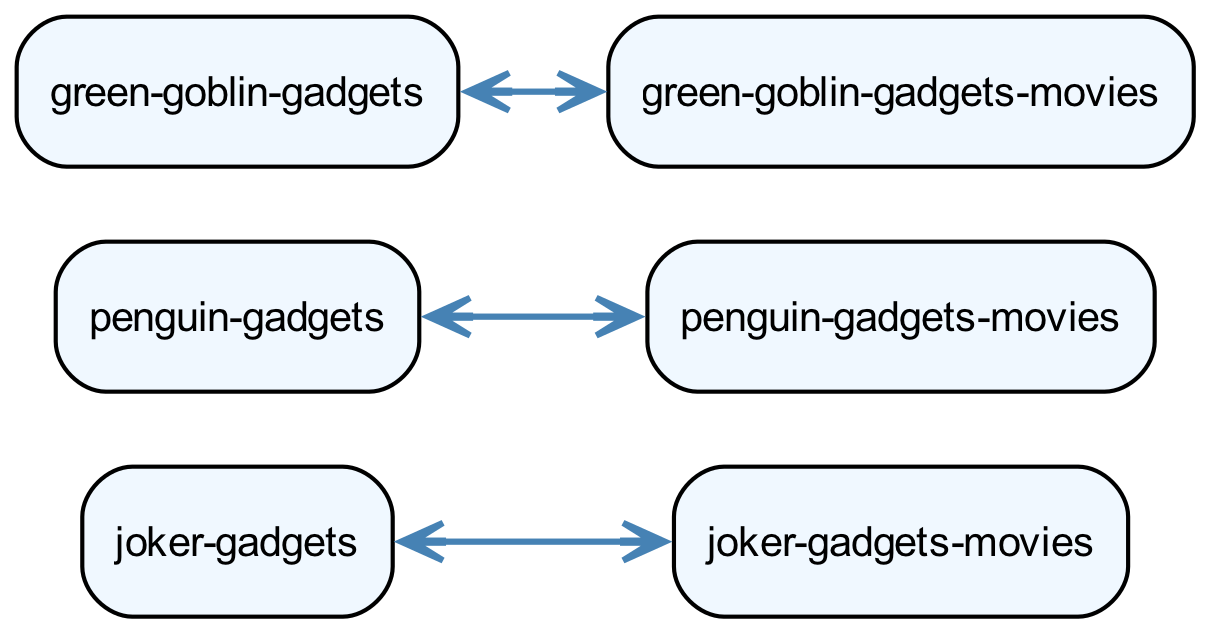What are the main media types depicted in the diagram? The diagram depicts two main media types: Comic Books and Movies, shown as the primary nodes. The relationships between other nodes branch out from these two categories.
Answer: Comic Books, Movies How many gadgets are associated with the Joker in comic books? In the diagram, the Joker's Gadgets in comic books are detailed with two: Laughing Gas and Acid Flower. Counting these gives a total of two gadgets.
Answer: 2 What gadget is common to both the Joker in comic books and movies? The diagram links the Joker's Gadgets from comic books to movies, but the specific gadgets are not the same. However, both categories of gadgets represent the Joker himself, showing a connection.
Answer: Joker's Gadgets How many gadgets does the Penguin have in movies? In the Penguin's section from the Movies, there are two gadgets listed: Missile Umbrella and Duck Boat. Thus, the total count of Penguin gadgets in movies from the diagram is two.
Answer: 2 Which villain is associated with both Pumpkin Bombs and Glider? The diagram indicates these gadgets belong to the Green Goblin, as they are listed under Green Goblin's Gadgets in the Spider-Man Comics section. This distinction helps in identifying the correct villain.
Answer: Green Goblin What is the relationship between Joker's Gadgets in comic books and their corresponding gadgets in movies? The diagram shows a direct link (edge) between Joker's Gadgets in comic books and Joker's Gadgets in movies, indicating that the gadgets from comics influenced those in movies.
Answer: Link (Joker's Gadgets) What unique gadget does the Penguin utilize in movies that is not found in comic books? The Penguin's gadgets in movies include the Missile Umbrella and Duck Boat, while the comic books only showcase the Trick Umbrella. This highlights the differences in their gadgetry across media.
Answer: Missile Umbrella Which vehicle belongs to the Green Goblin in movies? According to the diagram, the Bladed Glider is specifically listed under Green Goblin's Gadgets in the Spider-Man Movies section, making it the identified vehicle of the Green Goblin in that medium.
Answer: Bladed Glider How does the number of gadgets for the Green Goblin in comic books compare to those in movies? The diagram lists two gadgets for the Green Goblin in comic books (Pumpkin Bombs and Goblin Glider) and two gadgets in movies (Bladed Glider and Smoke Bombs), indicating an equal number across both media.
Answer: Equal (2) 